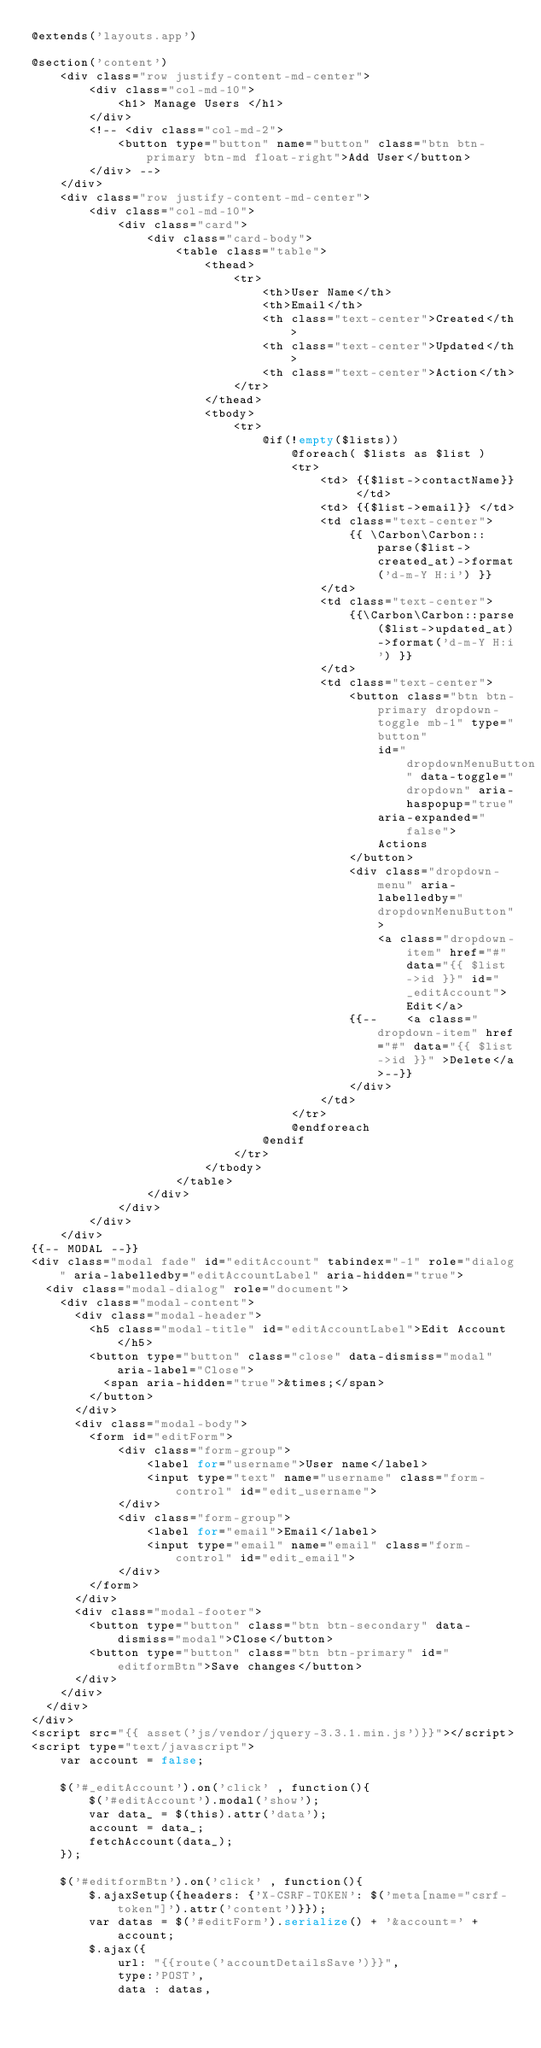Convert code to text. <code><loc_0><loc_0><loc_500><loc_500><_PHP_>@extends('layouts.app')

@section('content')
    <div class="row justify-content-md-center">
        <div class="col-md-10">
            <h1> Manage Users </h1>
        </div>
        <!-- <div class="col-md-2">
            <button type="button" name="button" class="btn btn-primary btn-md float-right">Add User</button>
        </div> -->
    </div>
    <div class="row justify-content-md-center">
        <div class="col-md-10">
            <div class="card">
                <div class="card-body">
                    <table class="table">
                        <thead>
                            <tr>
                                <th>User Name</th>
                                <th>Email</th>
                                <th class="text-center">Created</th>
                                <th class="text-center">Updated</th>
                                <th class="text-center">Action</th>
                            </tr>
                        </thead>
                        <tbody>
                            <tr>
                                @if(!empty($lists))
                                    @foreach( $lists as $list )
                                    <tr>
                                        <td> {{$list->contactName}} </td>
                                        <td> {{$list->email}} </td>
                                        <td class="text-center"> 
                                            {{ \Carbon\Carbon::parse($list->created_at)->format('d-m-Y H:i') }} 
                                        </td>
                                        <td class="text-center"> 
                                            {{\Carbon\Carbon::parse($list->updated_at)->format('d-m-Y H:i') }}
                                        </td>
                                        <td class="text-center">
                                            <button class="btn btn-primary dropdown-toggle mb-1" type="button"
                                                id="dropdownMenuButton" data-toggle="dropdown" aria-haspopup="true"
                                                aria-expanded="false">
                                                Actions
                                            </button>
                                            <div class="dropdown-menu" aria-labelledby="dropdownMenuButton">
                                                <a class="dropdown-item" href="#" data="{{ $list->id }}" id="_editAccount">Edit</a>
                                            {{--    <a class="dropdown-item" href="#" data="{{ $list->id }}" >Delete</a>--}}
                                            </div>
                                        </td>
                                    </tr>
                                    @endforeach
                                @endif
                            </tr>
                        </tbody>
                    </table>
                </div>
            </div>
        </div>
    </div>
{{-- MODAL --}}
<div class="modal fade" id="editAccount" tabindex="-1" role="dialog" aria-labelledby="editAccountLabel" aria-hidden="true">
  <div class="modal-dialog" role="document">
    <div class="modal-content">
      <div class="modal-header">
        <h5 class="modal-title" id="editAccountLabel">Edit Account</h5>
        <button type="button" class="close" data-dismiss="modal" aria-label="Close">
          <span aria-hidden="true">&times;</span>
        </button>
      </div>
      <div class="modal-body">
        <form id="editForm">
            <div class="form-group">
                <label for="username">User name</label>
                <input type="text" name="username" class="form-control" id="edit_username">
            </div>
            <div class="form-group">
                <label for="email">Email</label>
                <input type="email" name="email" class="form-control" id="edit_email">
            </div>
        </form>
      </div>
      <div class="modal-footer">
        <button type="button" class="btn btn-secondary" data-dismiss="modal">Close</button>
        <button type="button" class="btn btn-primary" id="editformBtn">Save changes</button>
      </div>
    </div>
  </div>
</div>
<script src="{{ asset('js/vendor/jquery-3.3.1.min.js')}}"></script>
<script type="text/javascript">
    var account = false;
    
    $('#_editAccount').on('click' , function(){
        $('#editAccount').modal('show');
        var data_ = $(this).attr('data');
        account = data_;
        fetchAccount(data_);
    });
    
    $('#editformBtn').on('click' , function(){
        $.ajaxSetup({headers: {'X-CSRF-TOKEN': $('meta[name="csrf-token"]').attr('content')}});
        var datas = $('#editForm').serialize() + '&account=' + account;
        $.ajax({
            url: "{{route('accountDetailsSave')}}",
            type:'POST',
            data : datas,</code> 